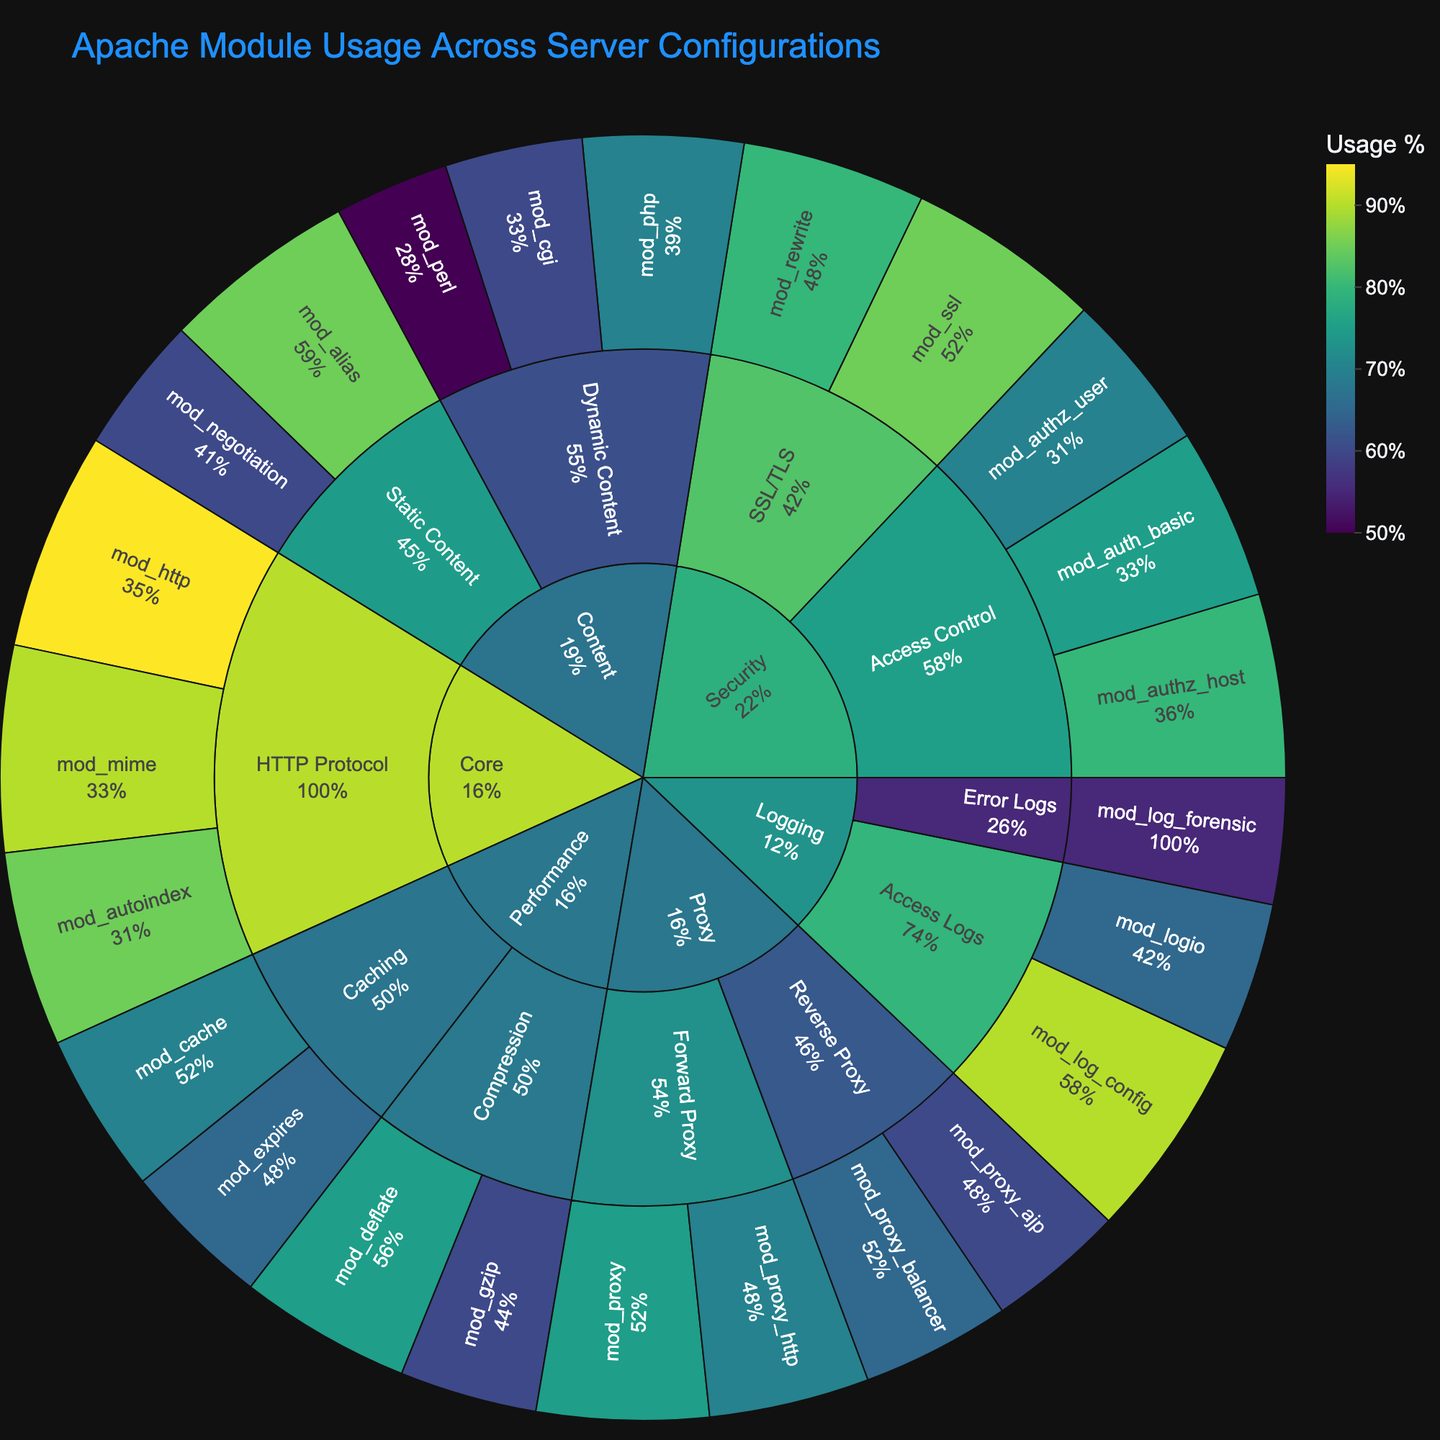What is the title of the plot? The title is displayed at the top of the plot and should directly mention the topic being visualized.
Answer: Apache Module Usage Across Server Configurations Which core module related to HTTP Protocol has the highest usage? Look at the Core category and find the HTTP Protocol subcategory, then check the module with the highest percentage.
Answer: mod_http How many modules are there in the Security category? Identify the Security category, and count all modules displayed under its subcategories.
Answer: 6 Which subcategory under Performance has the highest module usage percentage, and what is it? Look at the Performance category, compare the top modules in Caching and Compression subcategories, and identify the highest value.
Answer: Caching, mod_cache with 70% Is the mod_rewrite module used more in SSL/TLS than the mod_log_forensic module in Error Logs? Compare the usage percentages of mod_rewrite (SSL/TLS) and mod_log_forensic (Error Logs) directly from the plot.
Answer: Yes, 80% vs 55% What is the percentage difference between mod_php and mod_perl in the Dynamic Content subcategory? Find the usage of mod_php and mod_perl under Dynamic Content, and subtract the smaller percentage from the larger one.
Answer: 20% Which subcategory in the Proxy category has a higher total usage value and what is it? Sum the usage values of modules in Forward Proxy and Reverse Proxy, then compare the totals to identify the higher one. More detailed explanation: Forward Proxy: 75% (mod_proxy) + 70% (mod_proxy_http) = 145%. Reverse Proxy: 65% (mod_proxy_balancer) + 60% (mod_proxy_ajp) = 125%.
Answer: Forward Proxy, 145% What is the second most used module in the Logging category? Identify the Logging category and list modules in descending order of usage percentage, then find the second entry.
Answer: mod_logio Which subcategory under Security has more modules, Access Control or SSL/TLS? Count the modules in the Access Control and SSL/TLS subcategories and compare the totals.
Answer: Access Control 